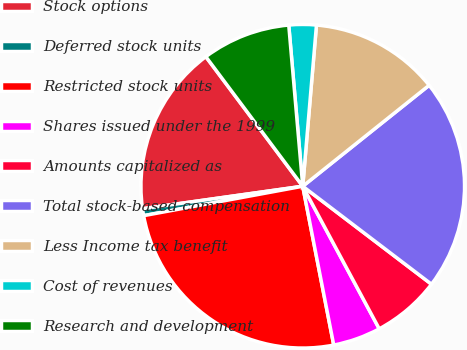<chart> <loc_0><loc_0><loc_500><loc_500><pie_chart><fcel>Stock options<fcel>Deferred stock units<fcel>Restricted stock units<fcel>Shares issued under the 1999<fcel>Amounts capitalized as<fcel>Total stock-based compensation<fcel>Less Income tax benefit<fcel>Cost of revenues<fcel>Research and development<nl><fcel>17.0%<fcel>0.69%<fcel>25.16%<fcel>4.77%<fcel>6.81%<fcel>21.08%<fcel>12.92%<fcel>2.73%<fcel>8.84%<nl></chart> 